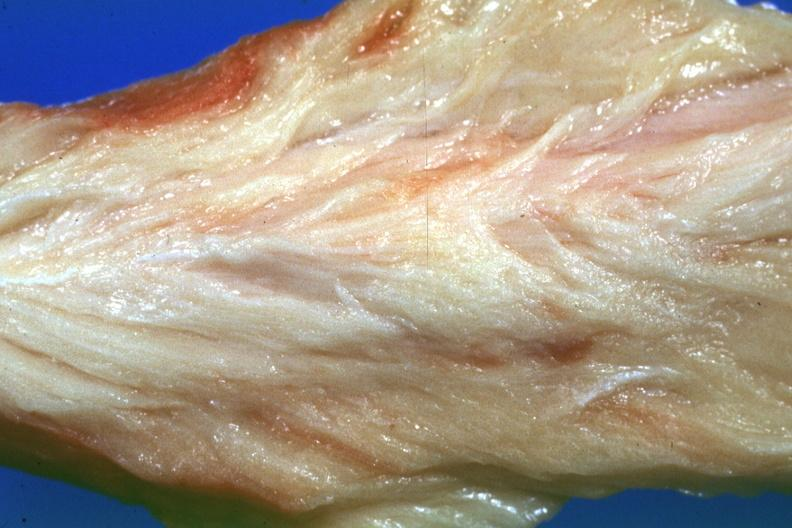s stress present?
Answer the question using a single word or phrase. No 